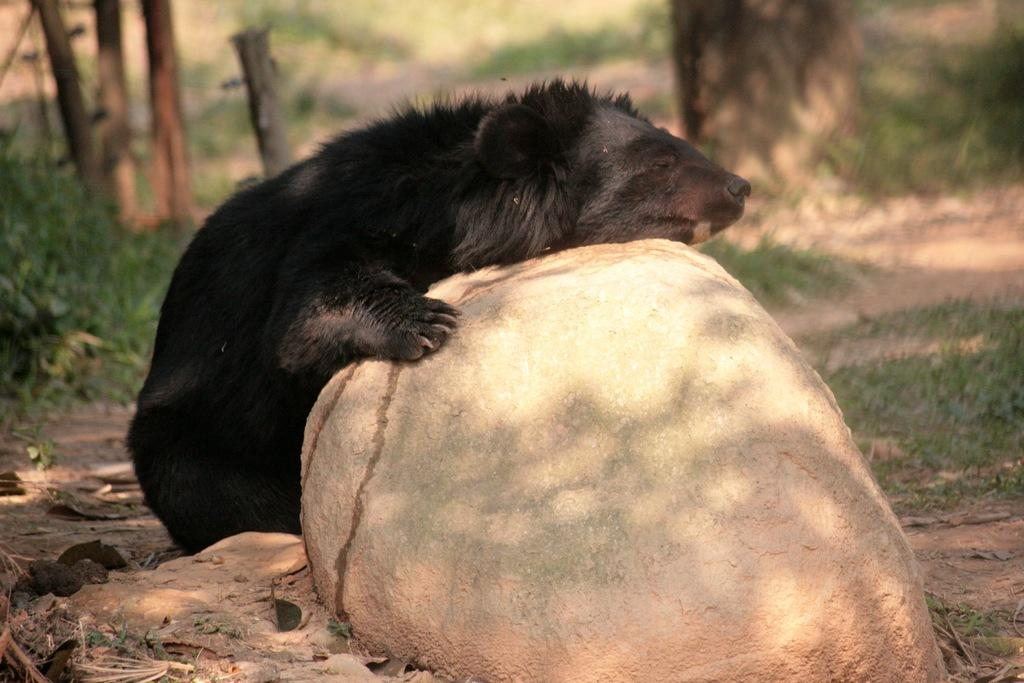What type of animal can be seen on the ground in the image? There is an animal on the ground in the image, but the specific type cannot be determined from the provided facts. What other objects or features are present in the image? There is a rock, grass, and trees in the image. Can you describe the background of the image? The background of the image is blurry. What tax rate is applied to the grandmother's income in the image? There is no mention of a grandmother or income in the image, so it is not possible to determine the tax rate. 